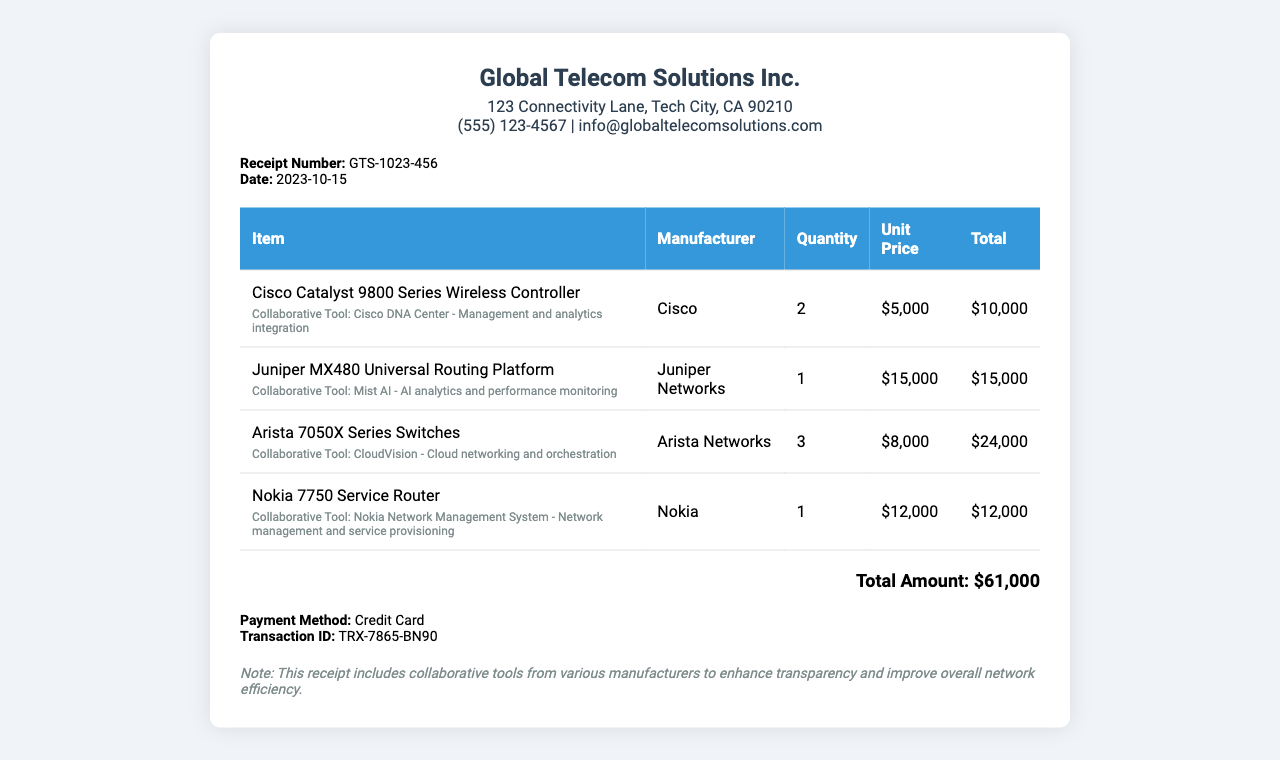What is the company name? The company name is prominently displayed at the top of the receipt.
Answer: Global Telecom Solutions Inc What is the receipt number? The receipt number is listed in the receipt details section.
Answer: GTS-1023-456 What is the total amount? The total amount is stated at the bottom of the receipt.
Answer: $61,000 What is the payment method? The payment method is provided in the payment information section.
Answer: Credit Card How many Cisco Catalyst 9800 Series Wireless Controllers were purchased? The quantity purchased is detailed in the item row for that equipment.
Answer: 2 What collaborative tool is associated with the Cisco equipment? The collaborative tool is mentioned in the same row as the Cisco equipment.
Answer: Cisco DNA Center Which manufacturer provides the Mist AI tool? The manufacturer associated with Mist AI is noted in the item row for Juniper MX480.
Answer: Juniper Networks What is the unit price of the Arista 7050X Series Switches? The unit price is provided in the corresponding table cell for that item.
Answer: $8,000 What note is included at the bottom of the receipt? The note appears at the bottom of the receipt under the notes section.
Answer: This receipt includes collaborative tools from various manufacturers to enhance transparency and improve overall network efficiency 